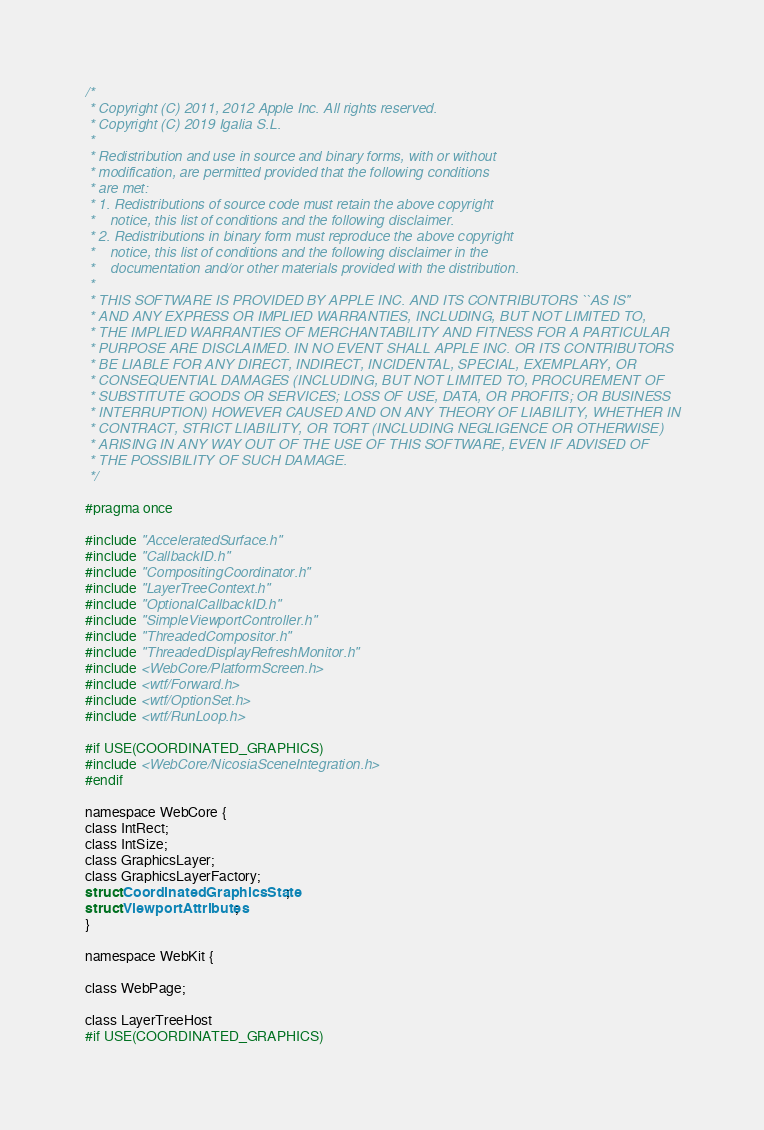Convert code to text. <code><loc_0><loc_0><loc_500><loc_500><_C_>/*
 * Copyright (C) 2011, 2012 Apple Inc. All rights reserved.
 * Copyright (C) 2019 Igalia S.L.
 *
 * Redistribution and use in source and binary forms, with or without
 * modification, are permitted provided that the following conditions
 * are met:
 * 1. Redistributions of source code must retain the above copyright
 *    notice, this list of conditions and the following disclaimer.
 * 2. Redistributions in binary form must reproduce the above copyright
 *    notice, this list of conditions and the following disclaimer in the
 *    documentation and/or other materials provided with the distribution.
 *
 * THIS SOFTWARE IS PROVIDED BY APPLE INC. AND ITS CONTRIBUTORS ``AS IS''
 * AND ANY EXPRESS OR IMPLIED WARRANTIES, INCLUDING, BUT NOT LIMITED TO,
 * THE IMPLIED WARRANTIES OF MERCHANTABILITY AND FITNESS FOR A PARTICULAR
 * PURPOSE ARE DISCLAIMED. IN NO EVENT SHALL APPLE INC. OR ITS CONTRIBUTORS
 * BE LIABLE FOR ANY DIRECT, INDIRECT, INCIDENTAL, SPECIAL, EXEMPLARY, OR
 * CONSEQUENTIAL DAMAGES (INCLUDING, BUT NOT LIMITED TO, PROCUREMENT OF
 * SUBSTITUTE GOODS OR SERVICES; LOSS OF USE, DATA, OR PROFITS; OR BUSINESS
 * INTERRUPTION) HOWEVER CAUSED AND ON ANY THEORY OF LIABILITY, WHETHER IN
 * CONTRACT, STRICT LIABILITY, OR TORT (INCLUDING NEGLIGENCE OR OTHERWISE)
 * ARISING IN ANY WAY OUT OF THE USE OF THIS SOFTWARE, EVEN IF ADVISED OF
 * THE POSSIBILITY OF SUCH DAMAGE.
 */

#pragma once

#include "AcceleratedSurface.h"
#include "CallbackID.h"
#include "CompositingCoordinator.h"
#include "LayerTreeContext.h"
#include "OptionalCallbackID.h"
#include "SimpleViewportController.h"
#include "ThreadedCompositor.h"
#include "ThreadedDisplayRefreshMonitor.h"
#include <WebCore/PlatformScreen.h>
#include <wtf/Forward.h>
#include <wtf/OptionSet.h>
#include <wtf/RunLoop.h>

#if USE(COORDINATED_GRAPHICS)
#include <WebCore/NicosiaSceneIntegration.h>
#endif

namespace WebCore {
class IntRect;
class IntSize;
class GraphicsLayer;
class GraphicsLayerFactory;
struct CoordinatedGraphicsState;
struct ViewportAttributes;
}

namespace WebKit {

class WebPage;

class LayerTreeHost
#if USE(COORDINATED_GRAPHICS)</code> 